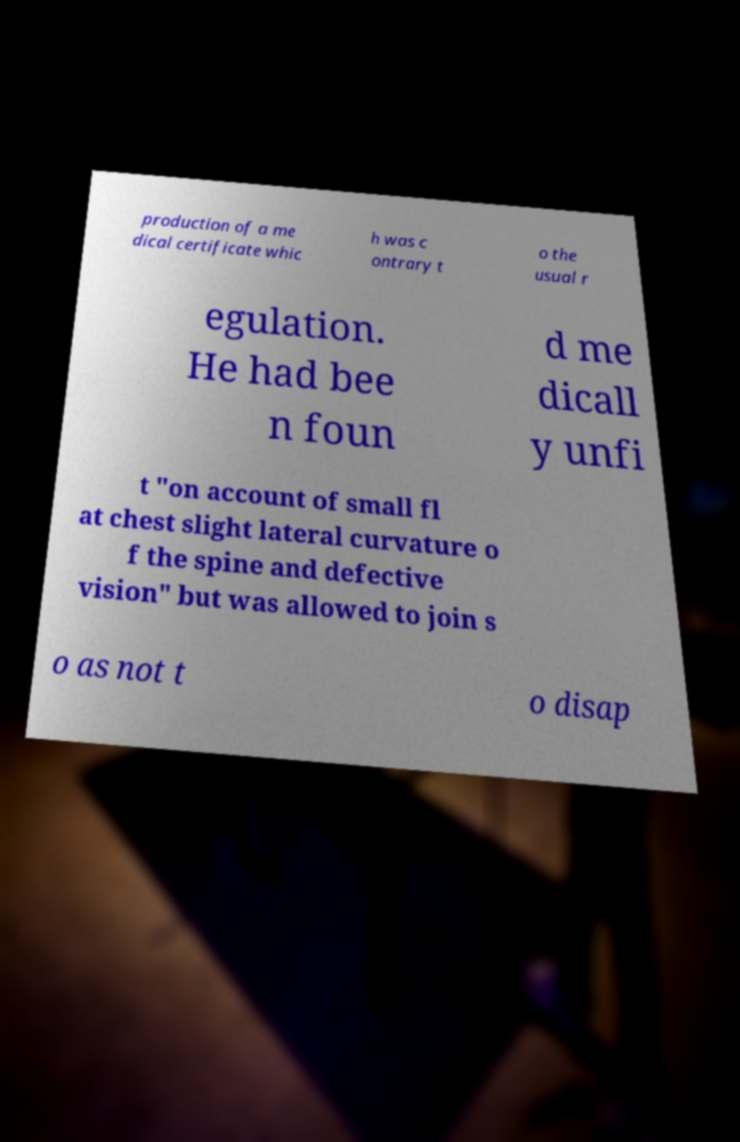Can you read and provide the text displayed in the image?This photo seems to have some interesting text. Can you extract and type it out for me? production of a me dical certificate whic h was c ontrary t o the usual r egulation. He had bee n foun d me dicall y unfi t "on account of small fl at chest slight lateral curvature o f the spine and defective vision" but was allowed to join s o as not t o disap 